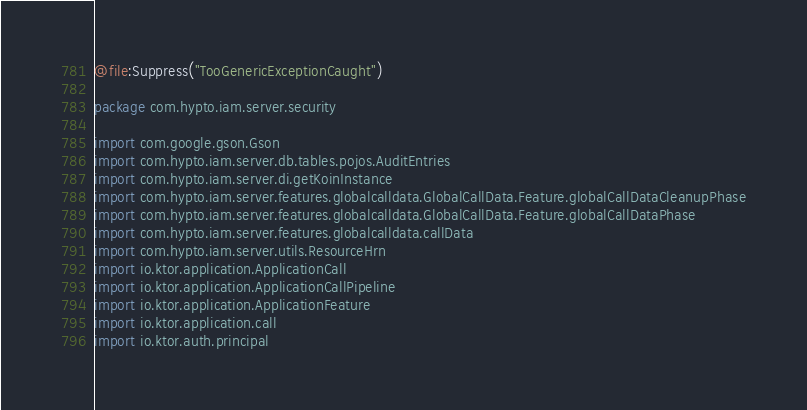Convert code to text. <code><loc_0><loc_0><loc_500><loc_500><_Kotlin_>@file:Suppress("TooGenericExceptionCaught")

package com.hypto.iam.server.security

import com.google.gson.Gson
import com.hypto.iam.server.db.tables.pojos.AuditEntries
import com.hypto.iam.server.di.getKoinInstance
import com.hypto.iam.server.features.globalcalldata.GlobalCallData.Feature.globalCallDataCleanupPhase
import com.hypto.iam.server.features.globalcalldata.GlobalCallData.Feature.globalCallDataPhase
import com.hypto.iam.server.features.globalcalldata.callData
import com.hypto.iam.server.utils.ResourceHrn
import io.ktor.application.ApplicationCall
import io.ktor.application.ApplicationCallPipeline
import io.ktor.application.ApplicationFeature
import io.ktor.application.call
import io.ktor.auth.principal</code> 